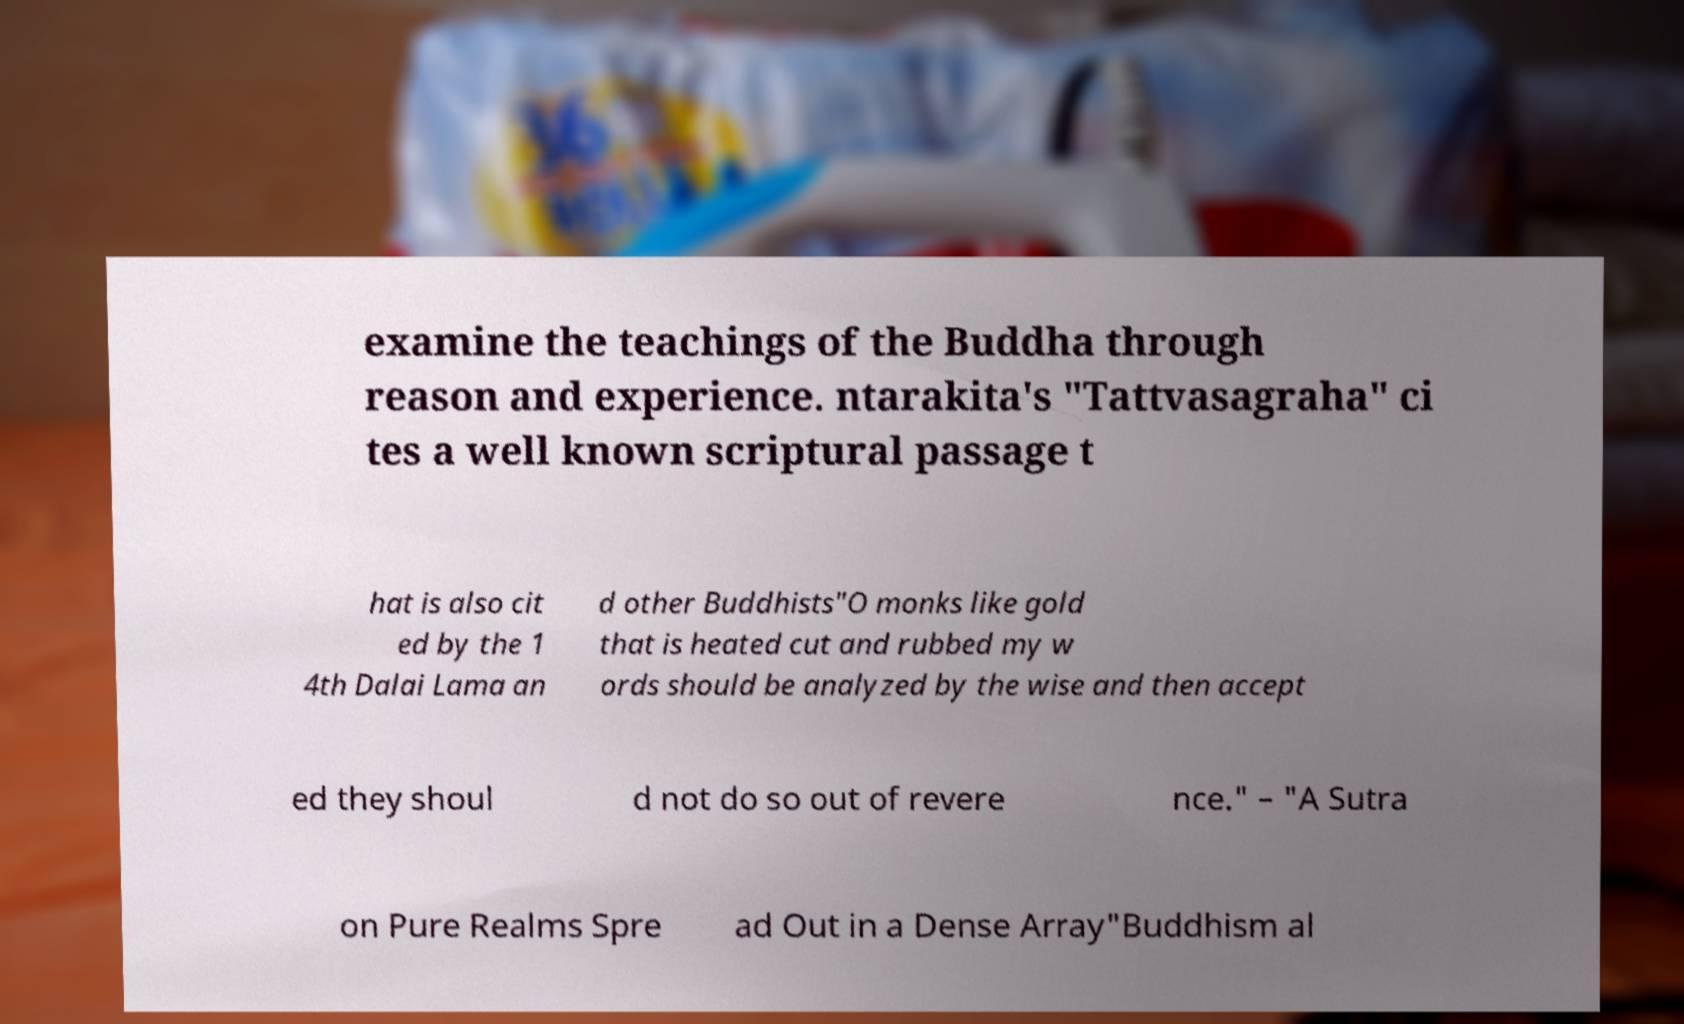Can you accurately transcribe the text from the provided image for me? examine the teachings of the Buddha through reason and experience. ntarakita's "Tattvasagraha" ci tes a well known scriptural passage t hat is also cit ed by the 1 4th Dalai Lama an d other Buddhists"O monks like gold that is heated cut and rubbed my w ords should be analyzed by the wise and then accept ed they shoul d not do so out of revere nce." – "A Sutra on Pure Realms Spre ad Out in a Dense Array"Buddhism al 